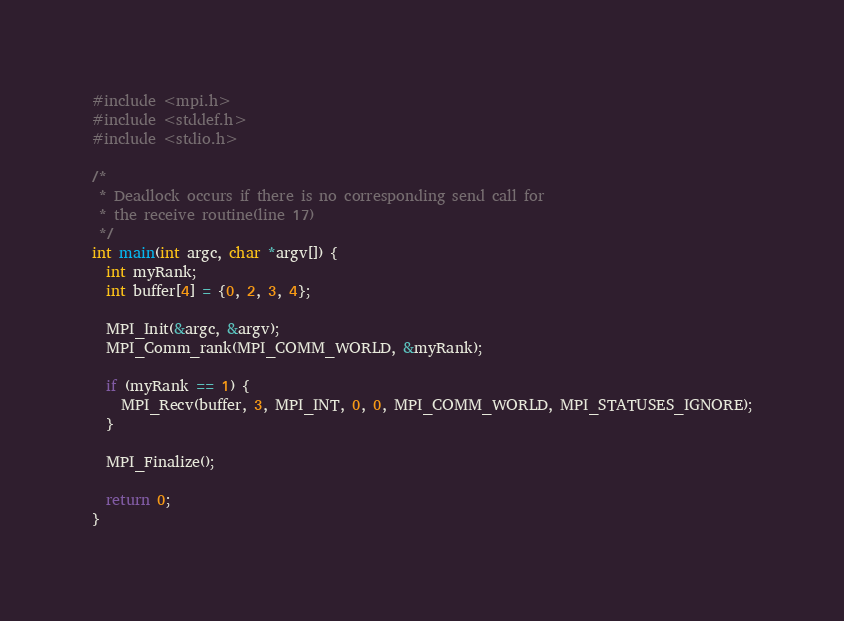<code> <loc_0><loc_0><loc_500><loc_500><_C_>#include <mpi.h>
#include <stddef.h>
#include <stdio.h>

/*
 * Deadlock occurs if there is no corresponding send call for
 * the receive routine(line 17)
 */
int main(int argc, char *argv[]) {
  int myRank;
  int buffer[4] = {0, 2, 3, 4};

  MPI_Init(&argc, &argv);
  MPI_Comm_rank(MPI_COMM_WORLD, &myRank);

  if (myRank == 1) {
    MPI_Recv(buffer, 3, MPI_INT, 0, 0, MPI_COMM_WORLD, MPI_STATUSES_IGNORE);
  }

  MPI_Finalize();

  return 0;
}
</code> 